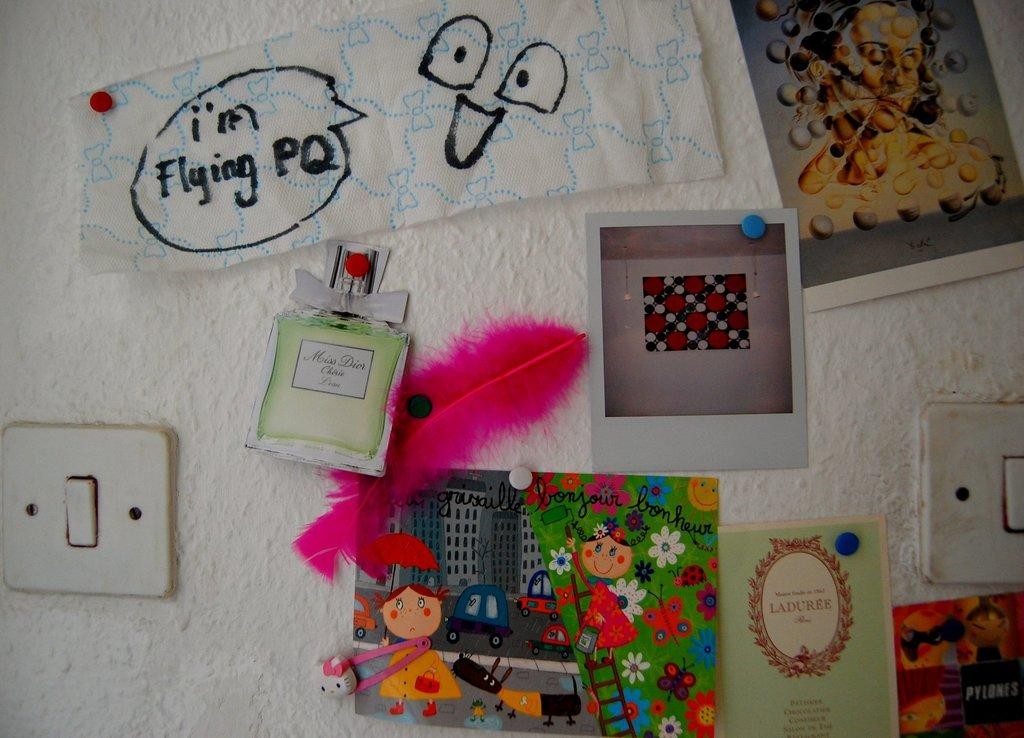<image>
Offer a succinct explanation of the picture presented. A number of things hang on a wall, one of which is a napkin with i'm Flying PQ written on it with a smiley face. 